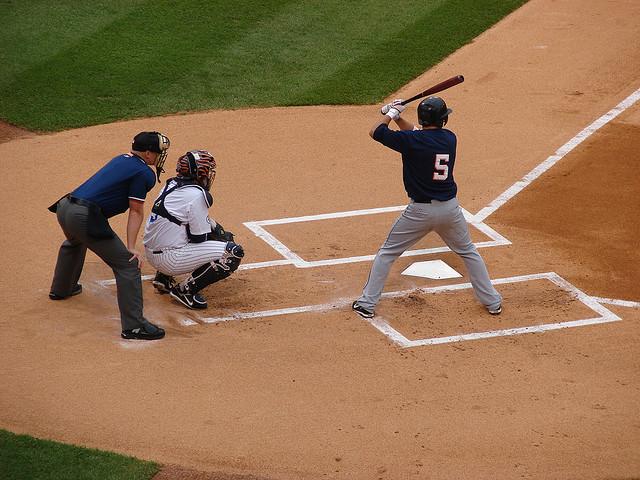What is the batters number?
Answer briefly. 5. What color are the painted lines on the field?
Quick response, please. White. What sport is this?
Quick response, please. Baseball. Who has number five on his t shirt?
Quick response, please. Batter. 